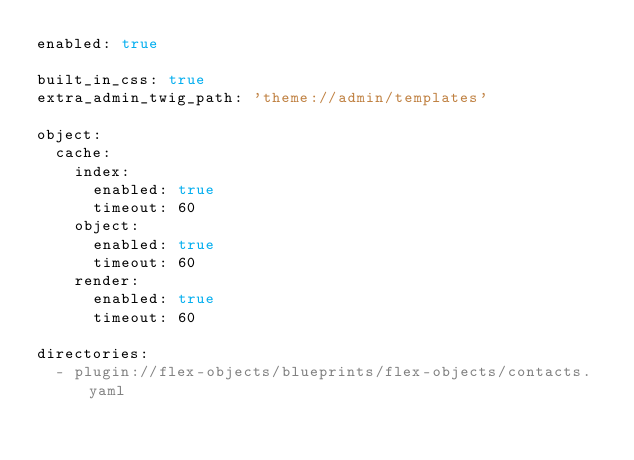Convert code to text. <code><loc_0><loc_0><loc_500><loc_500><_YAML_>enabled: true

built_in_css: true
extra_admin_twig_path: 'theme://admin/templates'

object:
  cache:
    index:
      enabled: true
      timeout: 60
    object:
      enabled: true
      timeout: 60
    render:
      enabled: true
      timeout: 60

directories:
  - plugin://flex-objects/blueprints/flex-objects/contacts.yaml
</code> 